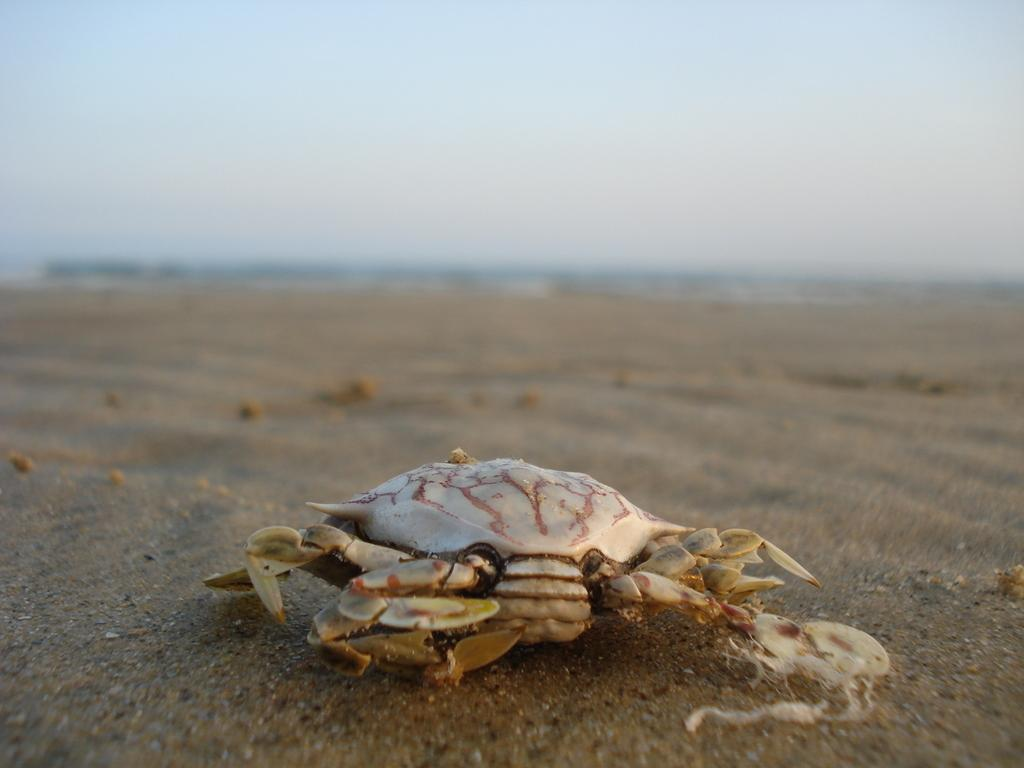What is the main subject of the image? The main subject of the image is a crap. Where is the crap located in the image? The crap is on the sand. What decision does the manager make regarding the tin in the image? There is no manager or tin present in the image, so no such decision can be made. 